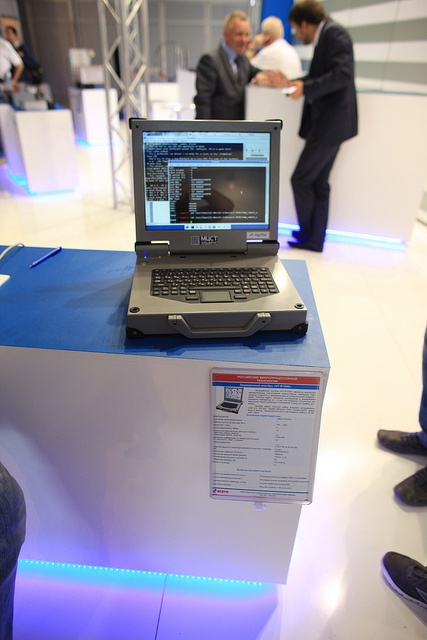Describe the objects in this image and their specific colors. I can see laptop in gray, black, and lightblue tones, people in gray, black, darkgray, and brown tones, people in gray, black, brown, and tan tones, people in gray, black, beige, and navy tones, and people in gray, ivory, tan, and brown tones in this image. 